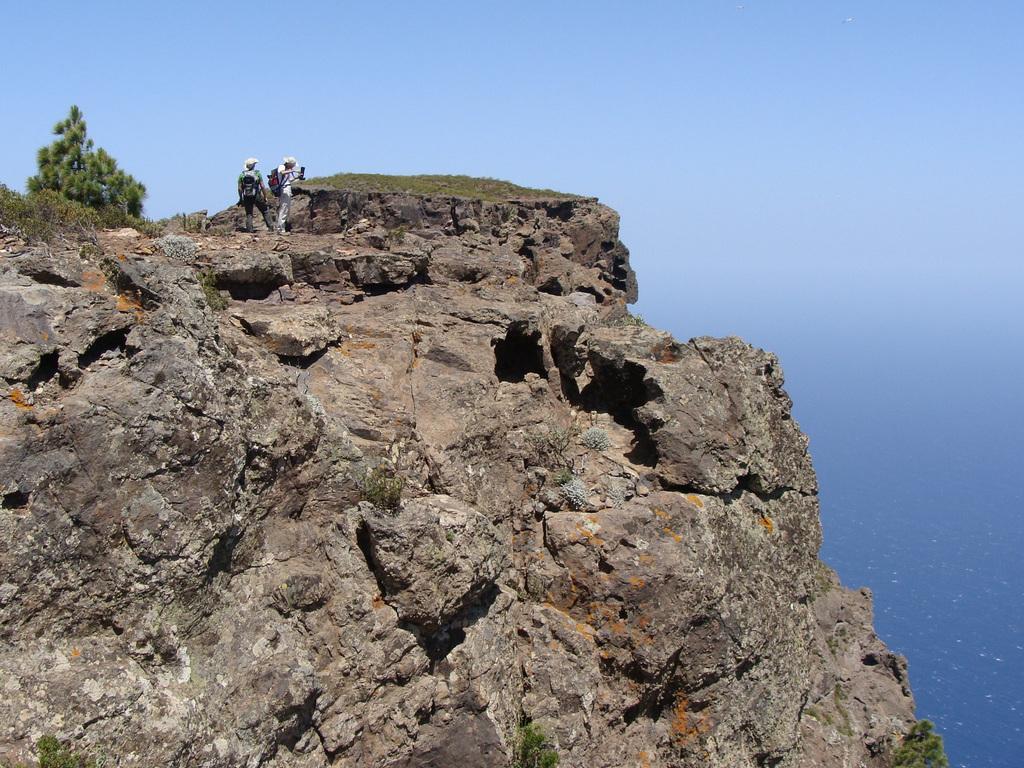In one or two sentences, can you explain what this image depicts? Here in this picture we can see people standing on the mountains and we can also see some part of ground is covered with grass, plants and trees and we can see the sky is clear and we can see water present in the bottom. 